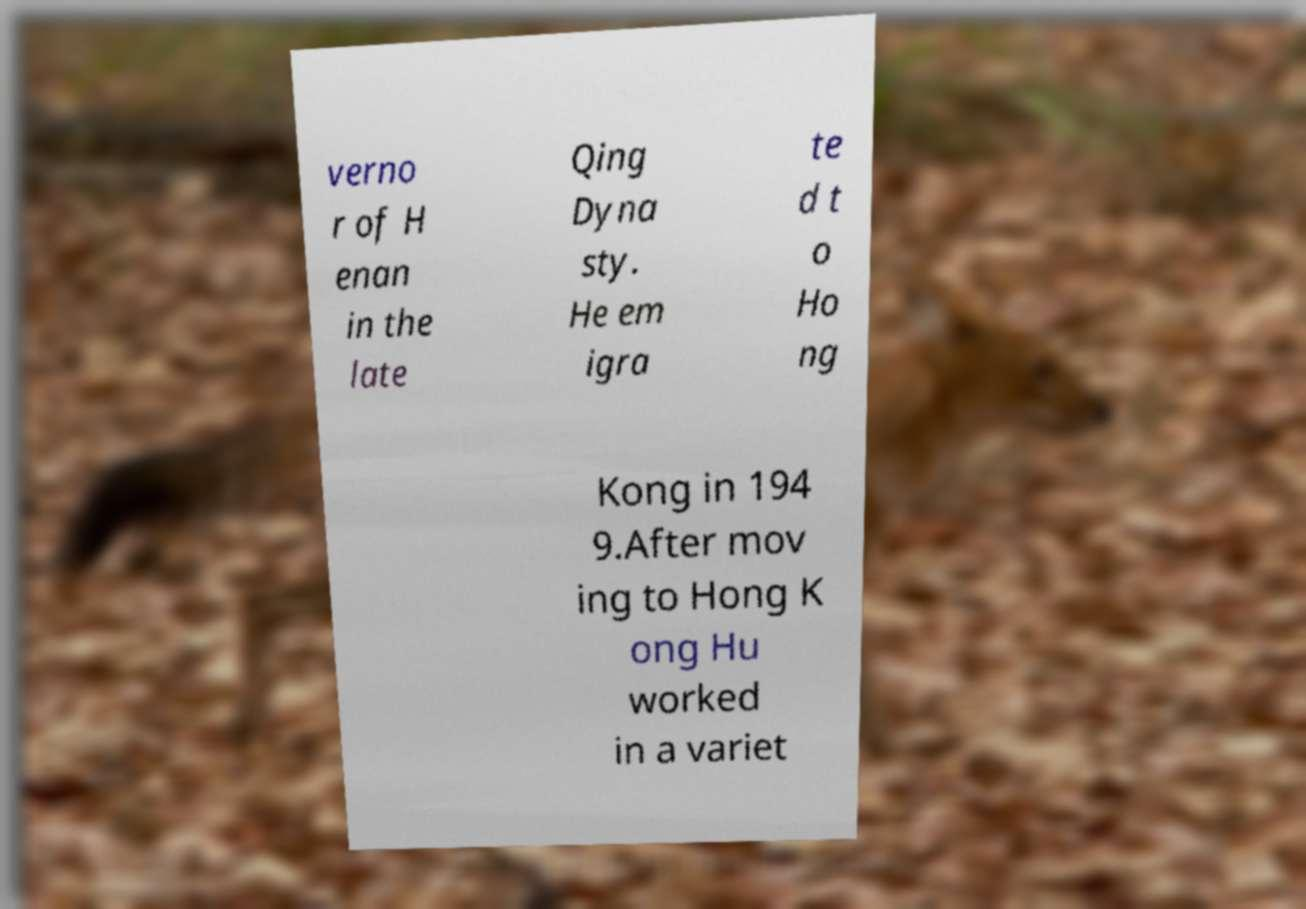Can you read and provide the text displayed in the image?This photo seems to have some interesting text. Can you extract and type it out for me? verno r of H enan in the late Qing Dyna sty. He em igra te d t o Ho ng Kong in 194 9.After mov ing to Hong K ong Hu worked in a variet 